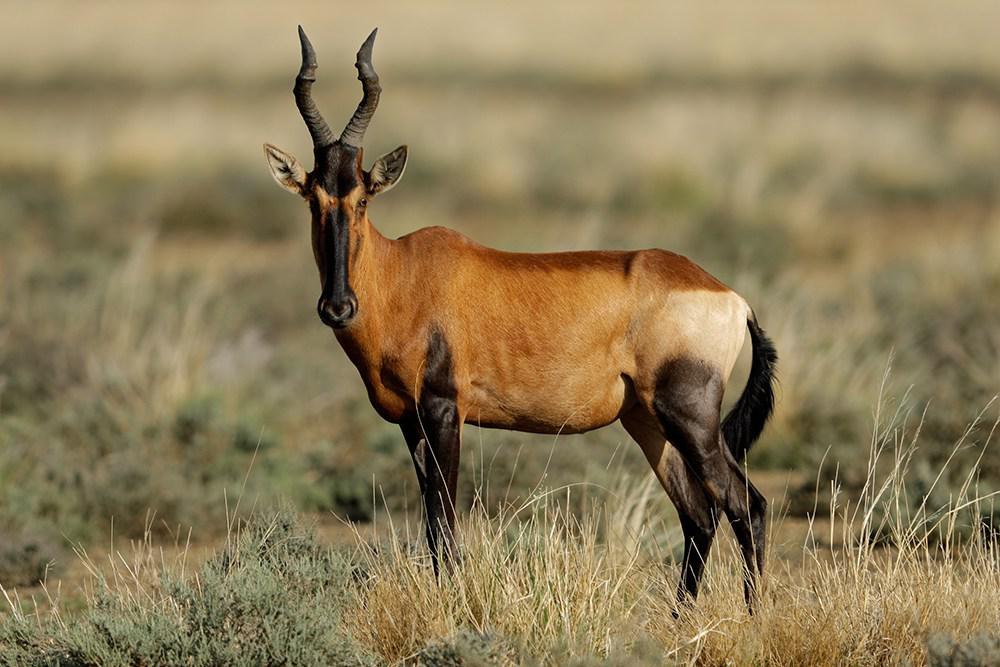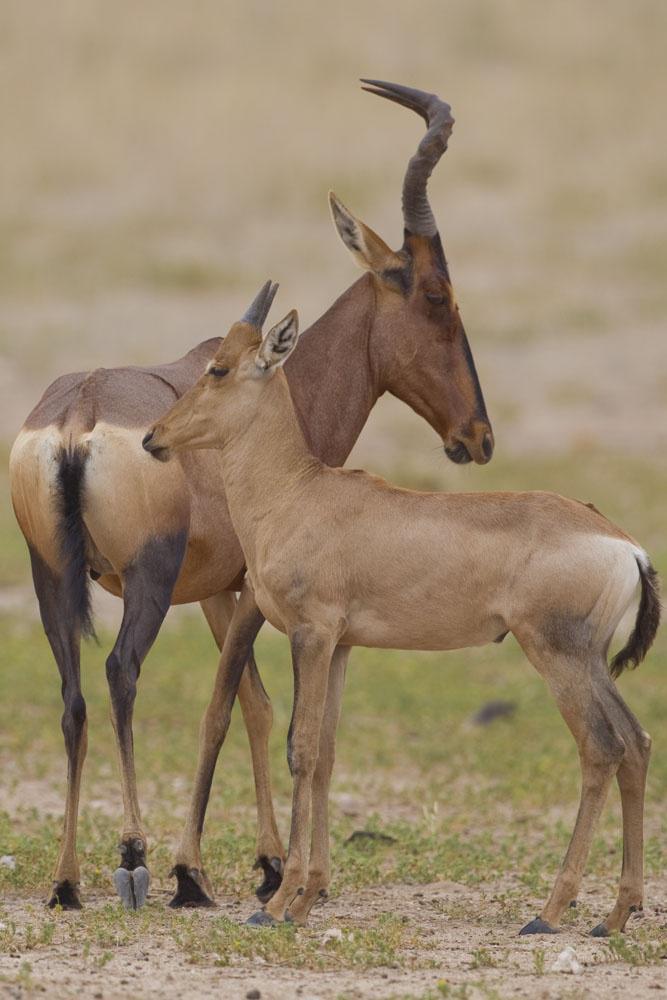The first image is the image on the left, the second image is the image on the right. For the images shown, is this caption "The horned animal on the left faces the camera directly, although its body is in full profile." true? Answer yes or no. Yes. 